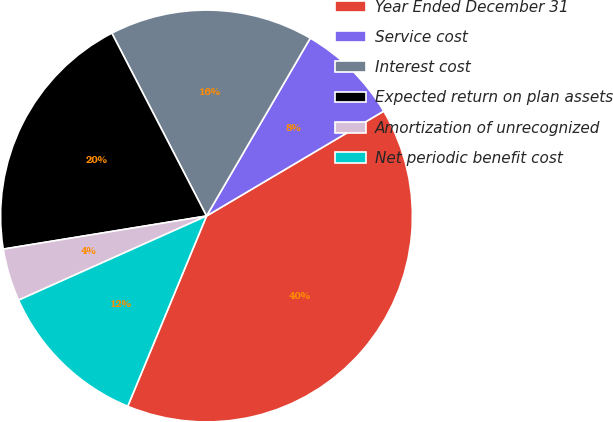Convert chart. <chart><loc_0><loc_0><loc_500><loc_500><pie_chart><fcel>Year Ended December 31<fcel>Service cost<fcel>Interest cost<fcel>Expected return on plan assets<fcel>Amortization of unrecognized<fcel>Net periodic benefit cost<nl><fcel>39.76%<fcel>8.09%<fcel>16.01%<fcel>19.97%<fcel>4.13%<fcel>12.05%<nl></chart> 